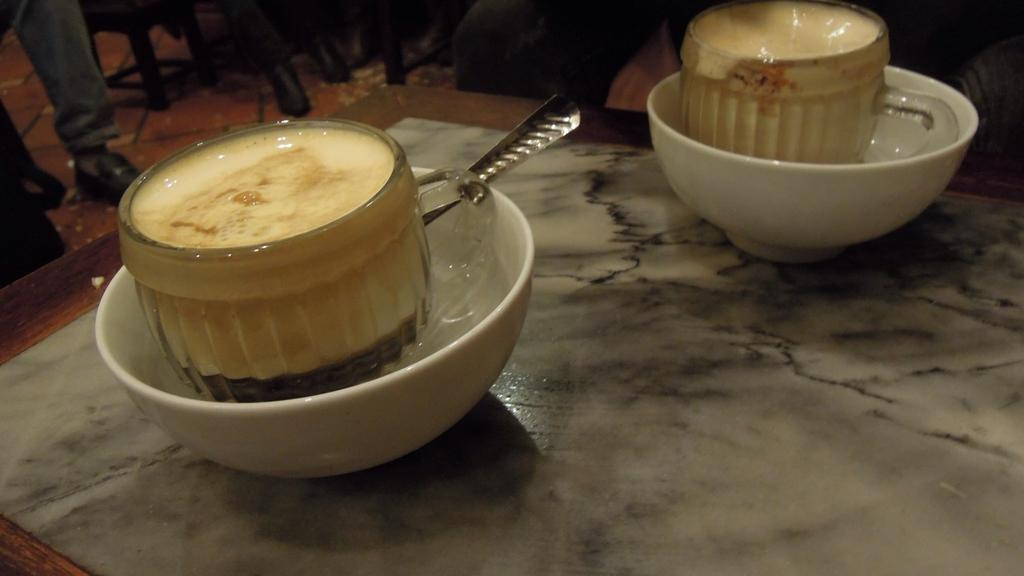How many tea cups are visible in the image? There are two tea cups in the image. What other items can be seen on the table in the image? There are bowls and a spoon visible on the table in the image. What might be used for stirring or scooping in the image? The spoon in the image can be used for stirring or scooping. What type of news can be heard coming from the radio on the bed in the image? There is no radio or bed present in the image; it only features tea cups, bowls, and a spoon on a table. 